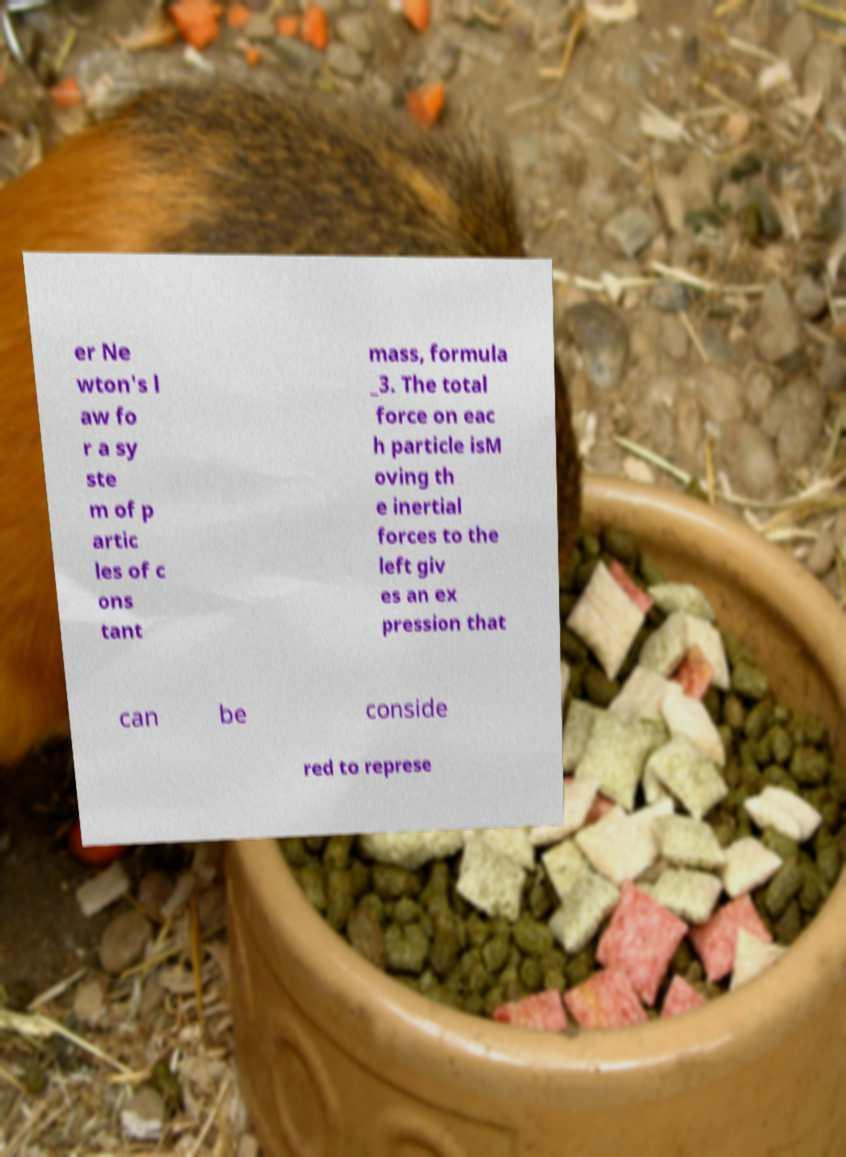There's text embedded in this image that I need extracted. Can you transcribe it verbatim? er Ne wton's l aw fo r a sy ste m of p artic les of c ons tant mass, formula _3. The total force on eac h particle isM oving th e inertial forces to the left giv es an ex pression that can be conside red to represe 